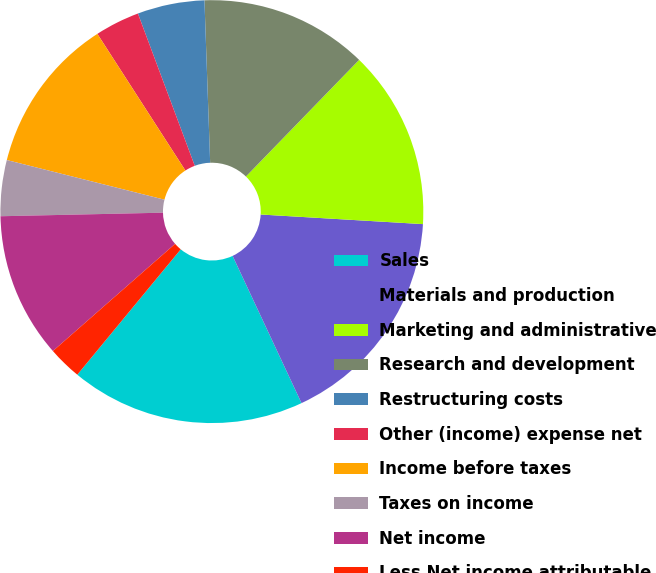Convert chart. <chart><loc_0><loc_0><loc_500><loc_500><pie_chart><fcel>Sales<fcel>Materials and production<fcel>Marketing and administrative<fcel>Research and development<fcel>Restructuring costs<fcel>Other (income) expense net<fcel>Income before taxes<fcel>Taxes on income<fcel>Net income<fcel>Less Net income attributable<nl><fcel>17.95%<fcel>17.09%<fcel>13.68%<fcel>12.82%<fcel>5.13%<fcel>3.42%<fcel>11.97%<fcel>4.27%<fcel>11.11%<fcel>2.56%<nl></chart> 